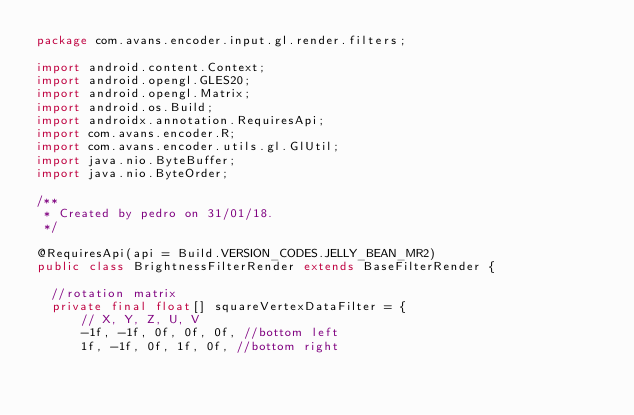Convert code to text. <code><loc_0><loc_0><loc_500><loc_500><_Java_>package com.avans.encoder.input.gl.render.filters;

import android.content.Context;
import android.opengl.GLES20;
import android.opengl.Matrix;
import android.os.Build;
import androidx.annotation.RequiresApi;
import com.avans.encoder.R;
import com.avans.encoder.utils.gl.GlUtil;
import java.nio.ByteBuffer;
import java.nio.ByteOrder;

/**
 * Created by pedro on 31/01/18.
 */

@RequiresApi(api = Build.VERSION_CODES.JELLY_BEAN_MR2)
public class BrightnessFilterRender extends BaseFilterRender {

  //rotation matrix
  private final float[] squareVertexDataFilter = {
      // X, Y, Z, U, V
      -1f, -1f, 0f, 0f, 0f, //bottom left
      1f, -1f, 0f, 1f, 0f, //bottom right</code> 